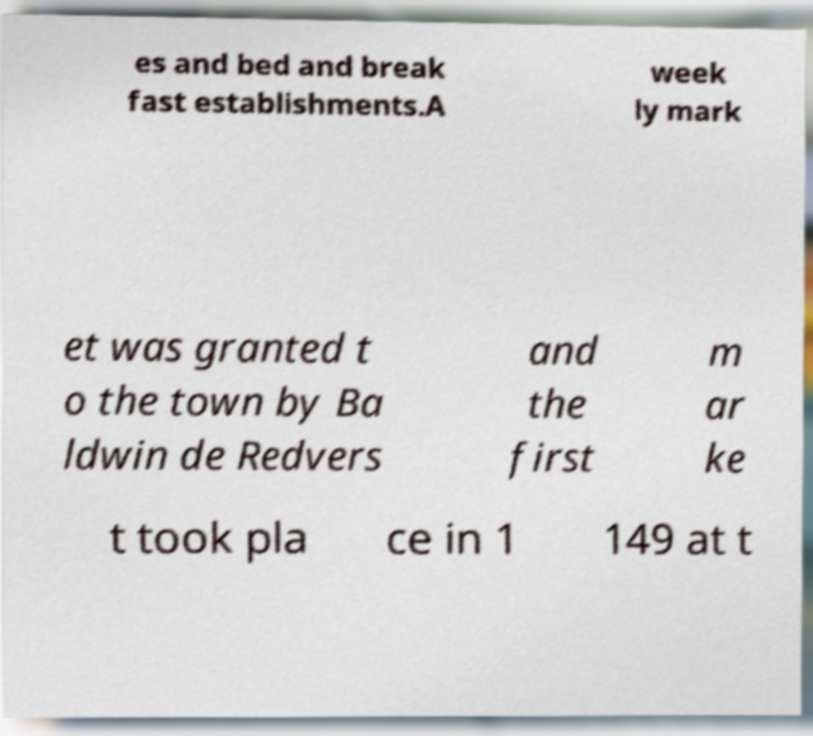For documentation purposes, I need the text within this image transcribed. Could you provide that? es and bed and break fast establishments.A week ly mark et was granted t o the town by Ba ldwin de Redvers and the first m ar ke t took pla ce in 1 149 at t 